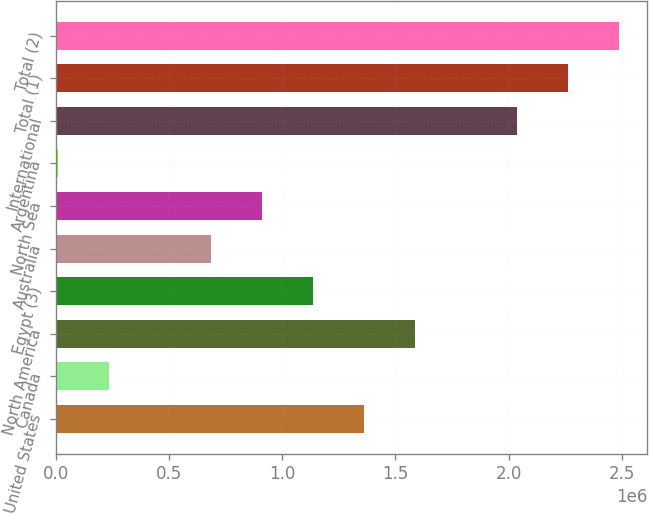Convert chart. <chart><loc_0><loc_0><loc_500><loc_500><bar_chart><fcel>United States<fcel>Canada<fcel>North America<fcel>Egypt (3)<fcel>Australia<fcel>North Sea<fcel>Argentina<fcel>International<fcel>Total (1)<fcel>Total (2)<nl><fcel>1.36127e+06<fcel>234876<fcel>1.58655e+06<fcel>1.13599e+06<fcel>685433<fcel>910712<fcel>9597<fcel>2.03711e+06<fcel>2.26238e+06<fcel>2.48766e+06<nl></chart> 